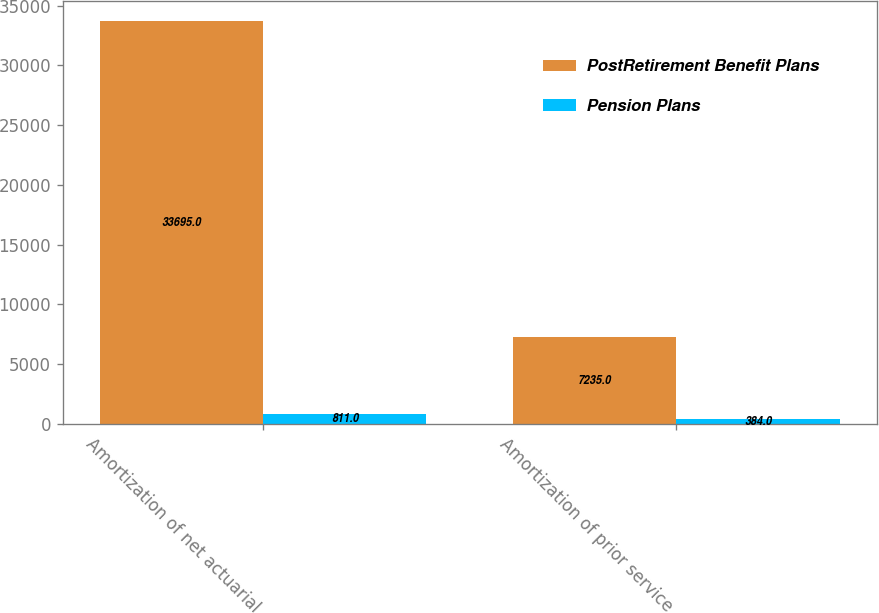Convert chart. <chart><loc_0><loc_0><loc_500><loc_500><stacked_bar_chart><ecel><fcel>Amortization of net actuarial<fcel>Amortization of prior service<nl><fcel>PostRetirement Benefit Plans<fcel>33695<fcel>7235<nl><fcel>Pension Plans<fcel>811<fcel>384<nl></chart> 